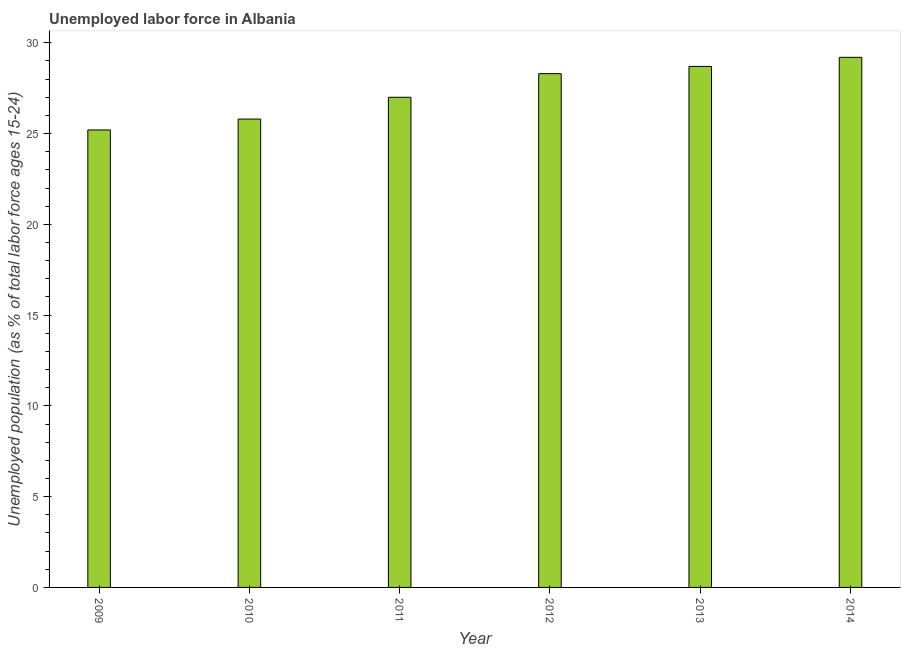Does the graph contain any zero values?
Your answer should be very brief. No. What is the title of the graph?
Provide a succinct answer. Unemployed labor force in Albania. What is the label or title of the Y-axis?
Provide a short and direct response. Unemployed population (as % of total labor force ages 15-24). What is the total unemployed youth population in 2013?
Give a very brief answer. 28.7. Across all years, what is the maximum total unemployed youth population?
Your answer should be compact. 29.2. Across all years, what is the minimum total unemployed youth population?
Give a very brief answer. 25.2. In which year was the total unemployed youth population minimum?
Offer a terse response. 2009. What is the sum of the total unemployed youth population?
Make the answer very short. 164.2. What is the average total unemployed youth population per year?
Provide a succinct answer. 27.37. What is the median total unemployed youth population?
Offer a very short reply. 27.65. In how many years, is the total unemployed youth population greater than 3 %?
Your response must be concise. 6. Do a majority of the years between 2014 and 2012 (inclusive) have total unemployed youth population greater than 22 %?
Make the answer very short. Yes. What is the ratio of the total unemployed youth population in 2012 to that in 2013?
Make the answer very short. 0.99. Is the total unemployed youth population in 2011 less than that in 2014?
Offer a terse response. Yes. Is the sum of the total unemployed youth population in 2011 and 2012 greater than the maximum total unemployed youth population across all years?
Your answer should be very brief. Yes. In how many years, is the total unemployed youth population greater than the average total unemployed youth population taken over all years?
Your answer should be compact. 3. How many years are there in the graph?
Your answer should be very brief. 6. Are the values on the major ticks of Y-axis written in scientific E-notation?
Offer a very short reply. No. What is the Unemployed population (as % of total labor force ages 15-24) of 2009?
Ensure brevity in your answer.  25.2. What is the Unemployed population (as % of total labor force ages 15-24) in 2010?
Your answer should be compact. 25.8. What is the Unemployed population (as % of total labor force ages 15-24) of 2012?
Keep it short and to the point. 28.3. What is the Unemployed population (as % of total labor force ages 15-24) in 2013?
Provide a succinct answer. 28.7. What is the Unemployed population (as % of total labor force ages 15-24) of 2014?
Provide a succinct answer. 29.2. What is the difference between the Unemployed population (as % of total labor force ages 15-24) in 2009 and 2011?
Give a very brief answer. -1.8. What is the difference between the Unemployed population (as % of total labor force ages 15-24) in 2010 and 2012?
Offer a very short reply. -2.5. What is the difference between the Unemployed population (as % of total labor force ages 15-24) in 2010 and 2013?
Offer a terse response. -2.9. What is the difference between the Unemployed population (as % of total labor force ages 15-24) in 2012 and 2013?
Offer a very short reply. -0.4. What is the difference between the Unemployed population (as % of total labor force ages 15-24) in 2013 and 2014?
Keep it short and to the point. -0.5. What is the ratio of the Unemployed population (as % of total labor force ages 15-24) in 2009 to that in 2011?
Keep it short and to the point. 0.93. What is the ratio of the Unemployed population (as % of total labor force ages 15-24) in 2009 to that in 2012?
Keep it short and to the point. 0.89. What is the ratio of the Unemployed population (as % of total labor force ages 15-24) in 2009 to that in 2013?
Offer a very short reply. 0.88. What is the ratio of the Unemployed population (as % of total labor force ages 15-24) in 2009 to that in 2014?
Keep it short and to the point. 0.86. What is the ratio of the Unemployed population (as % of total labor force ages 15-24) in 2010 to that in 2011?
Offer a terse response. 0.96. What is the ratio of the Unemployed population (as % of total labor force ages 15-24) in 2010 to that in 2012?
Your answer should be compact. 0.91. What is the ratio of the Unemployed population (as % of total labor force ages 15-24) in 2010 to that in 2013?
Offer a very short reply. 0.9. What is the ratio of the Unemployed population (as % of total labor force ages 15-24) in 2010 to that in 2014?
Keep it short and to the point. 0.88. What is the ratio of the Unemployed population (as % of total labor force ages 15-24) in 2011 to that in 2012?
Your response must be concise. 0.95. What is the ratio of the Unemployed population (as % of total labor force ages 15-24) in 2011 to that in 2013?
Your response must be concise. 0.94. What is the ratio of the Unemployed population (as % of total labor force ages 15-24) in 2011 to that in 2014?
Your answer should be very brief. 0.93. What is the ratio of the Unemployed population (as % of total labor force ages 15-24) in 2012 to that in 2014?
Make the answer very short. 0.97. What is the ratio of the Unemployed population (as % of total labor force ages 15-24) in 2013 to that in 2014?
Your answer should be compact. 0.98. 